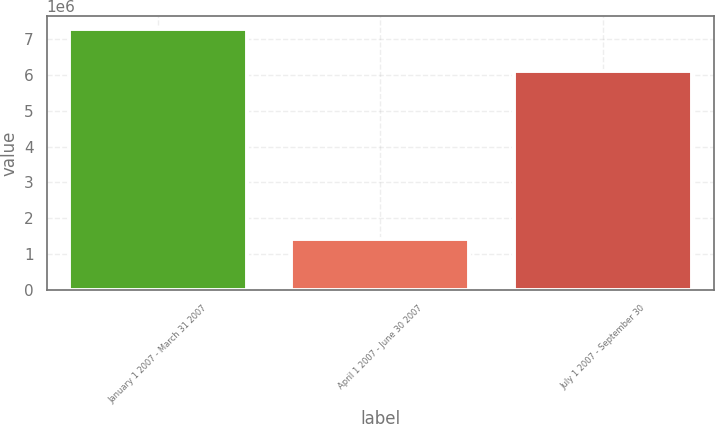Convert chart. <chart><loc_0><loc_0><loc_500><loc_500><bar_chart><fcel>January 1 2007 - March 31 2007<fcel>April 1 2007 - June 30 2007<fcel>July 1 2007 - September 30<nl><fcel>7.26145e+06<fcel>1.4371e+06<fcel>6.0914e+06<nl></chart> 